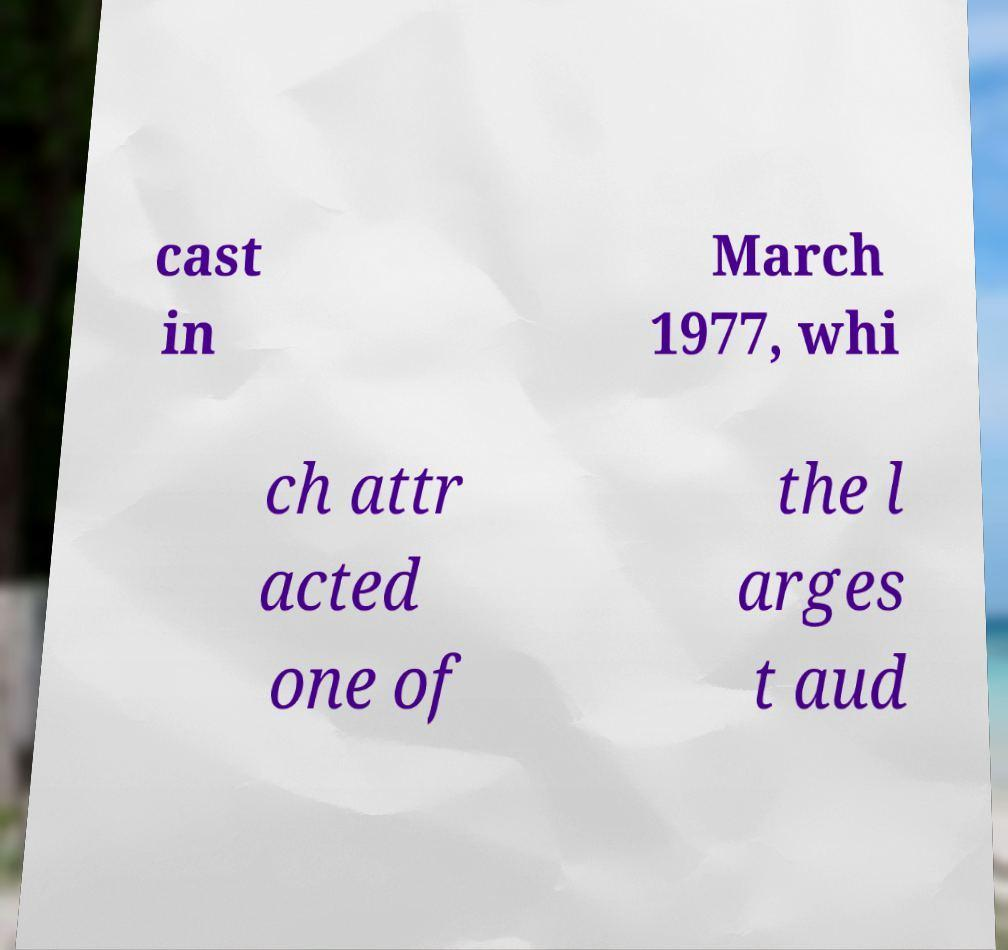Please identify and transcribe the text found in this image. cast in March 1977, whi ch attr acted one of the l arges t aud 